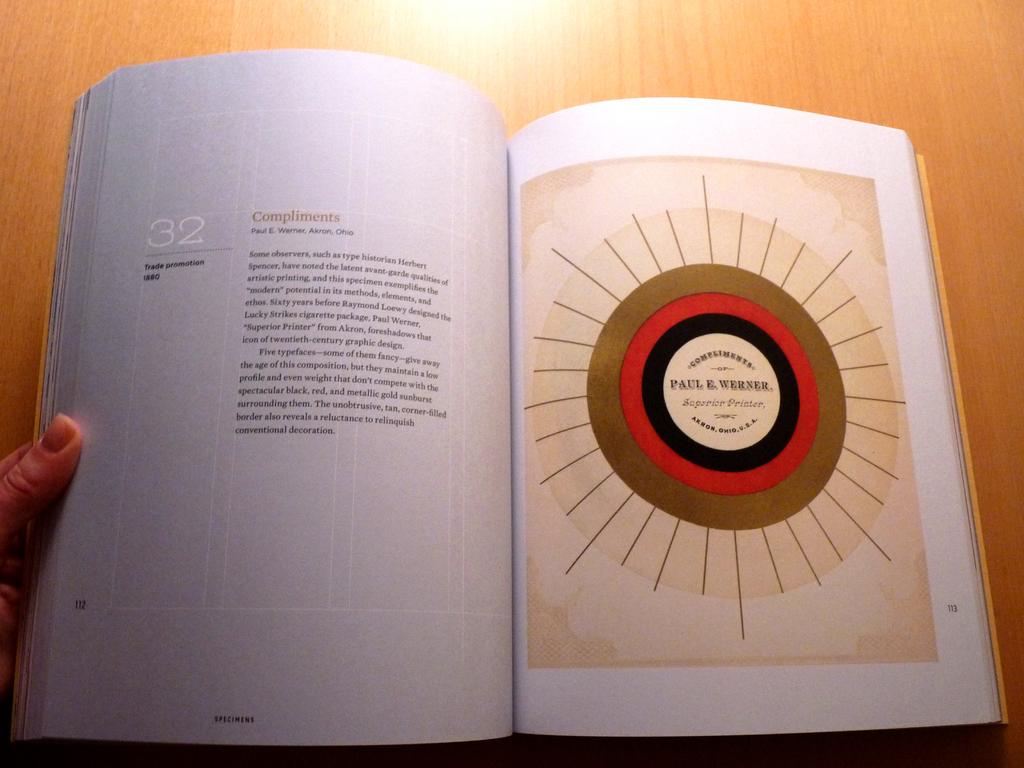What does the circle say?
Offer a very short reply. Paul e. werner. What state is mentioned on the left page?
Provide a succinct answer. Ohio. 